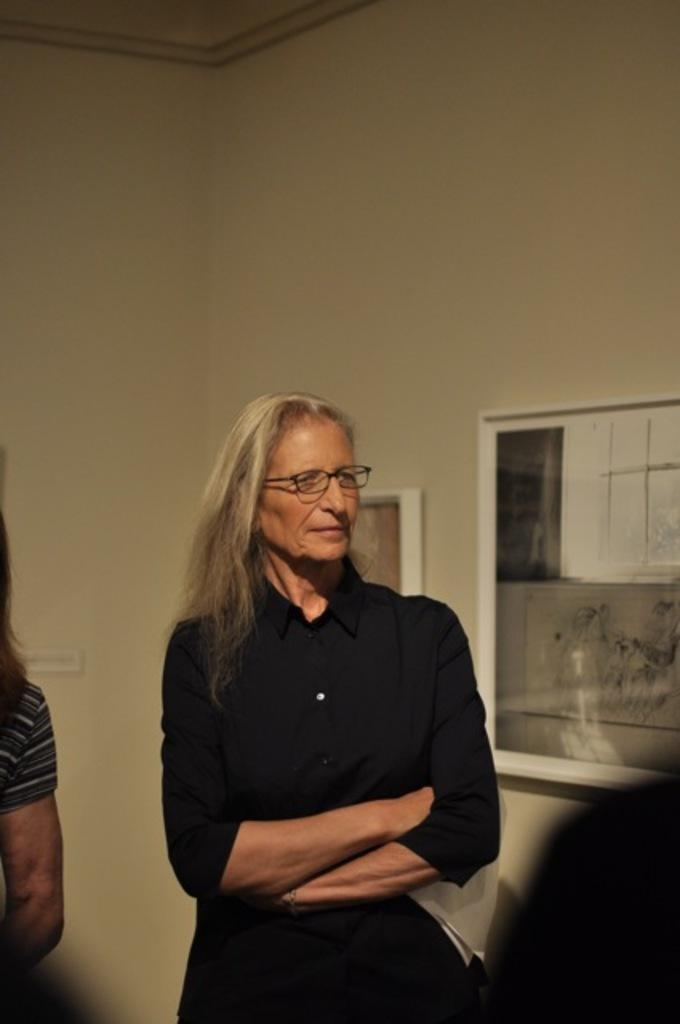Who is present in the image? There is a woman in the image. What is the woman wearing? The woman is wearing a black dress. What can be seen on the right side of the image? There is a window-like object on the right side of the image. Can you see any children playing near the lake in the image? There is no lake or children present in the image. What type of pipe is visible in the image? There is no pipe present in the image. 